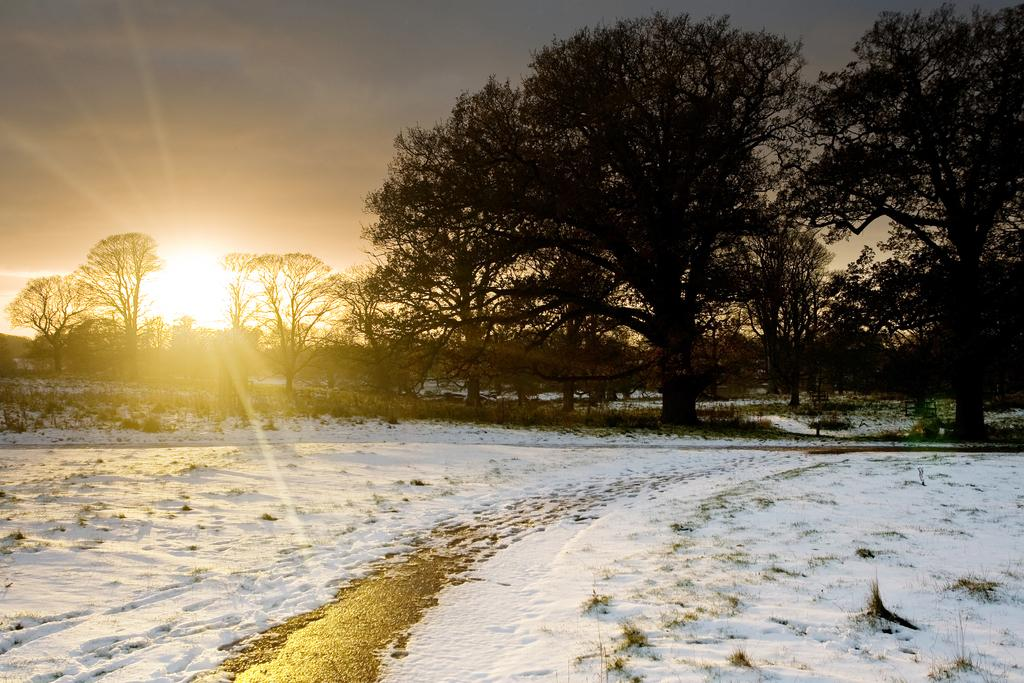What type of weather condition is depicted in the image? The image shows snow on the surface at the bottom, indicating a winter or cold weather condition. What can be seen in the background of the image? There are trees in the background of the image. What celestial body is visible in the image? The sun is visible in the image. What else is visible in the image besides the snow and trees? The sky is visible in the image. What type of coach can be seen in the image? There is no coach present in the image. How does the sun fold in the image? The sun does not fold in the image; it is a celestial body and cannot be folded. 